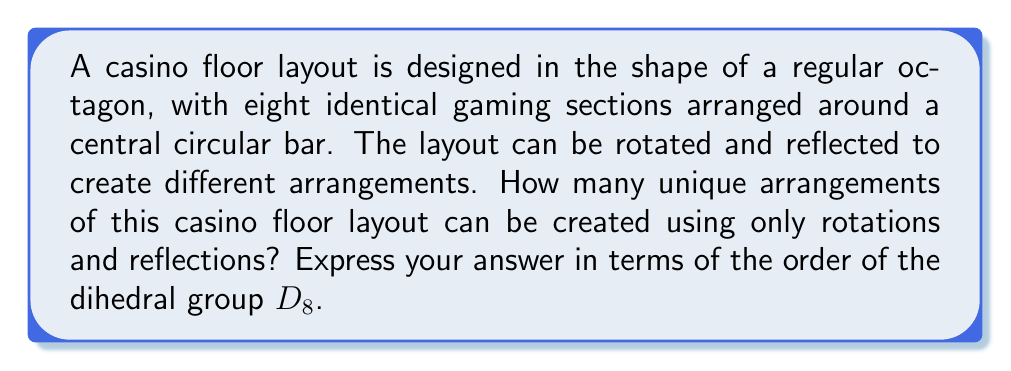Provide a solution to this math problem. To solve this problem, we need to apply the concepts of geometric group theory, specifically the properties of the dihedral group $D_8$, which describes the symmetries of a regular octagon.

1. First, let's recall the properties of the dihedral group $D_8$:
   - It has rotational symmetries of order 8 (including the identity rotation)
   - It has 8 reflection symmetries
   - The total order of $D_8$ is $8 + 8 = 16$

2. In this case, each symmetry operation (rotation or reflection) of $D_8$ corresponds to a unique arrangement of the casino floor layout.

3. The number of unique arrangements is equal to the number of elements in the group, which is the order of $D_8$.

4. Therefore, the number of unique arrangements is equal to $|D_8| = 16$.

To visualize this, we can represent the casino floor layout as follows:

[asy]
unitsize(1cm);
for(int i=0; i<8; ++i) {
  draw(rotate(45*i)*(1,0)--(cos(pi/8+pi*i/4),sin(pi/8+pi*i/4)), black+1);
}
draw(circle((0,0),0.3), gray);
label("Bar", (0,0), fontsize(8pt));
for(int i=0; i<8; ++i) {
  label(format("S%d", i+1), rotate(45*i)*(1.3,0), fontsize(8pt));
}
[/asy]

Where S1, S2, ..., S8 represent the eight identical gaming sections, and the central circle represents the bar.

Each element of $D_8$ will produce a unique arrangement of these sections around the central bar.
Answer: The number of unique arrangements is $|D_8| = 16$. 